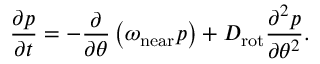<formula> <loc_0><loc_0><loc_500><loc_500>\frac { \partial p } { \partial t } = - \frac { \partial } { \partial \theta } \left ( \omega _ { n e a r } p \right ) + D _ { r o t } \frac { \partial ^ { 2 } p } { \partial \theta ^ { 2 } } .</formula> 